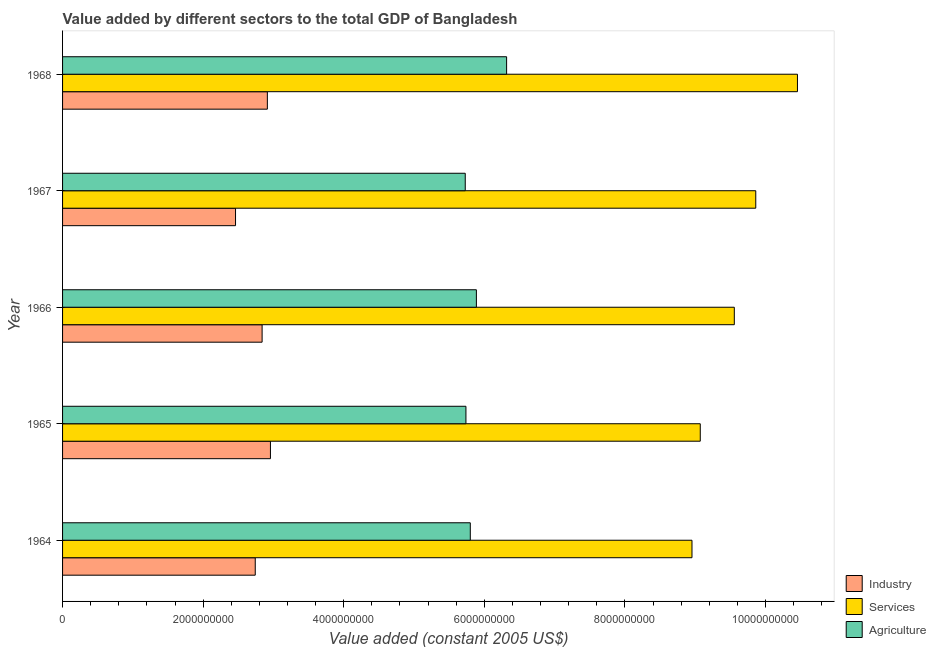Are the number of bars per tick equal to the number of legend labels?
Provide a short and direct response. Yes. What is the label of the 4th group of bars from the top?
Offer a terse response. 1965. What is the value added by services in 1964?
Make the answer very short. 8.95e+09. Across all years, what is the maximum value added by services?
Make the answer very short. 1.05e+1. Across all years, what is the minimum value added by agricultural sector?
Your response must be concise. 5.73e+09. In which year was the value added by agricultural sector maximum?
Your answer should be compact. 1968. In which year was the value added by services minimum?
Offer a very short reply. 1964. What is the total value added by industrial sector in the graph?
Make the answer very short. 1.39e+1. What is the difference between the value added by agricultural sector in 1964 and that in 1967?
Give a very brief answer. 7.18e+07. What is the difference between the value added by agricultural sector in 1964 and the value added by services in 1965?
Ensure brevity in your answer.  -3.27e+09. What is the average value added by industrial sector per year?
Your answer should be very brief. 2.78e+09. In the year 1965, what is the difference between the value added by industrial sector and value added by agricultural sector?
Your answer should be compact. -2.78e+09. What is the ratio of the value added by services in 1965 to that in 1966?
Offer a terse response. 0.95. What is the difference between the highest and the second highest value added by agricultural sector?
Provide a short and direct response. 4.30e+08. What is the difference between the highest and the lowest value added by agricultural sector?
Ensure brevity in your answer.  5.88e+08. Is the sum of the value added by industrial sector in 1964 and 1965 greater than the maximum value added by agricultural sector across all years?
Provide a short and direct response. No. What does the 3rd bar from the top in 1966 represents?
Provide a succinct answer. Industry. What does the 1st bar from the bottom in 1967 represents?
Your answer should be compact. Industry. How many bars are there?
Your response must be concise. 15. Are all the bars in the graph horizontal?
Your response must be concise. Yes. How many years are there in the graph?
Ensure brevity in your answer.  5. Are the values on the major ticks of X-axis written in scientific E-notation?
Offer a very short reply. No. Does the graph contain any zero values?
Make the answer very short. No. How many legend labels are there?
Ensure brevity in your answer.  3. How are the legend labels stacked?
Give a very brief answer. Vertical. What is the title of the graph?
Ensure brevity in your answer.  Value added by different sectors to the total GDP of Bangladesh. What is the label or title of the X-axis?
Your answer should be very brief. Value added (constant 2005 US$). What is the label or title of the Y-axis?
Provide a succinct answer. Year. What is the Value added (constant 2005 US$) of Industry in 1964?
Offer a very short reply. 2.74e+09. What is the Value added (constant 2005 US$) of Services in 1964?
Your answer should be very brief. 8.95e+09. What is the Value added (constant 2005 US$) of Agriculture in 1964?
Offer a very short reply. 5.80e+09. What is the Value added (constant 2005 US$) of Industry in 1965?
Your answer should be compact. 2.96e+09. What is the Value added (constant 2005 US$) of Services in 1965?
Keep it short and to the point. 9.07e+09. What is the Value added (constant 2005 US$) in Agriculture in 1965?
Your response must be concise. 5.74e+09. What is the Value added (constant 2005 US$) in Industry in 1966?
Ensure brevity in your answer.  2.84e+09. What is the Value added (constant 2005 US$) in Services in 1966?
Provide a succinct answer. 9.56e+09. What is the Value added (constant 2005 US$) of Agriculture in 1966?
Offer a very short reply. 5.89e+09. What is the Value added (constant 2005 US$) in Industry in 1967?
Offer a very short reply. 2.46e+09. What is the Value added (constant 2005 US$) in Services in 1967?
Provide a succinct answer. 9.86e+09. What is the Value added (constant 2005 US$) in Agriculture in 1967?
Offer a terse response. 5.73e+09. What is the Value added (constant 2005 US$) in Industry in 1968?
Provide a short and direct response. 2.91e+09. What is the Value added (constant 2005 US$) of Services in 1968?
Make the answer very short. 1.05e+1. What is the Value added (constant 2005 US$) of Agriculture in 1968?
Your answer should be compact. 6.32e+09. Across all years, what is the maximum Value added (constant 2005 US$) in Industry?
Provide a succinct answer. 2.96e+09. Across all years, what is the maximum Value added (constant 2005 US$) in Services?
Ensure brevity in your answer.  1.05e+1. Across all years, what is the maximum Value added (constant 2005 US$) of Agriculture?
Give a very brief answer. 6.32e+09. Across all years, what is the minimum Value added (constant 2005 US$) in Industry?
Provide a short and direct response. 2.46e+09. Across all years, what is the minimum Value added (constant 2005 US$) of Services?
Your response must be concise. 8.95e+09. Across all years, what is the minimum Value added (constant 2005 US$) in Agriculture?
Your answer should be very brief. 5.73e+09. What is the total Value added (constant 2005 US$) of Industry in the graph?
Keep it short and to the point. 1.39e+1. What is the total Value added (constant 2005 US$) of Services in the graph?
Your answer should be compact. 4.79e+1. What is the total Value added (constant 2005 US$) in Agriculture in the graph?
Provide a succinct answer. 2.95e+1. What is the difference between the Value added (constant 2005 US$) of Industry in 1964 and that in 1965?
Provide a short and direct response. -2.16e+08. What is the difference between the Value added (constant 2005 US$) of Services in 1964 and that in 1965?
Keep it short and to the point. -1.18e+08. What is the difference between the Value added (constant 2005 US$) in Agriculture in 1964 and that in 1965?
Your answer should be very brief. 6.19e+07. What is the difference between the Value added (constant 2005 US$) of Industry in 1964 and that in 1966?
Your answer should be very brief. -9.76e+07. What is the difference between the Value added (constant 2005 US$) in Services in 1964 and that in 1966?
Give a very brief answer. -6.02e+08. What is the difference between the Value added (constant 2005 US$) in Agriculture in 1964 and that in 1966?
Give a very brief answer. -8.68e+07. What is the difference between the Value added (constant 2005 US$) of Industry in 1964 and that in 1967?
Your answer should be very brief. 2.81e+08. What is the difference between the Value added (constant 2005 US$) of Services in 1964 and that in 1967?
Make the answer very short. -9.07e+08. What is the difference between the Value added (constant 2005 US$) of Agriculture in 1964 and that in 1967?
Make the answer very short. 7.18e+07. What is the difference between the Value added (constant 2005 US$) of Industry in 1964 and that in 1968?
Ensure brevity in your answer.  -1.72e+08. What is the difference between the Value added (constant 2005 US$) of Services in 1964 and that in 1968?
Your response must be concise. -1.50e+09. What is the difference between the Value added (constant 2005 US$) of Agriculture in 1964 and that in 1968?
Provide a short and direct response. -5.17e+08. What is the difference between the Value added (constant 2005 US$) in Industry in 1965 and that in 1966?
Your response must be concise. 1.19e+08. What is the difference between the Value added (constant 2005 US$) of Services in 1965 and that in 1966?
Offer a very short reply. -4.84e+08. What is the difference between the Value added (constant 2005 US$) in Agriculture in 1965 and that in 1966?
Offer a very short reply. -1.49e+08. What is the difference between the Value added (constant 2005 US$) of Industry in 1965 and that in 1967?
Provide a short and direct response. 4.97e+08. What is the difference between the Value added (constant 2005 US$) of Services in 1965 and that in 1967?
Make the answer very short. -7.89e+08. What is the difference between the Value added (constant 2005 US$) in Agriculture in 1965 and that in 1967?
Ensure brevity in your answer.  9.92e+06. What is the difference between the Value added (constant 2005 US$) in Industry in 1965 and that in 1968?
Provide a succinct answer. 4.39e+07. What is the difference between the Value added (constant 2005 US$) of Services in 1965 and that in 1968?
Provide a short and direct response. -1.38e+09. What is the difference between the Value added (constant 2005 US$) of Agriculture in 1965 and that in 1968?
Ensure brevity in your answer.  -5.78e+08. What is the difference between the Value added (constant 2005 US$) in Industry in 1966 and that in 1967?
Make the answer very short. 3.78e+08. What is the difference between the Value added (constant 2005 US$) of Services in 1966 and that in 1967?
Ensure brevity in your answer.  -3.05e+08. What is the difference between the Value added (constant 2005 US$) of Agriculture in 1966 and that in 1967?
Offer a terse response. 1.59e+08. What is the difference between the Value added (constant 2005 US$) of Industry in 1966 and that in 1968?
Provide a succinct answer. -7.46e+07. What is the difference between the Value added (constant 2005 US$) in Services in 1966 and that in 1968?
Give a very brief answer. -8.98e+08. What is the difference between the Value added (constant 2005 US$) in Agriculture in 1966 and that in 1968?
Your answer should be very brief. -4.30e+08. What is the difference between the Value added (constant 2005 US$) in Industry in 1967 and that in 1968?
Your answer should be very brief. -4.53e+08. What is the difference between the Value added (constant 2005 US$) of Services in 1967 and that in 1968?
Your answer should be compact. -5.93e+08. What is the difference between the Value added (constant 2005 US$) of Agriculture in 1967 and that in 1968?
Your answer should be very brief. -5.88e+08. What is the difference between the Value added (constant 2005 US$) of Industry in 1964 and the Value added (constant 2005 US$) of Services in 1965?
Offer a very short reply. -6.33e+09. What is the difference between the Value added (constant 2005 US$) in Industry in 1964 and the Value added (constant 2005 US$) in Agriculture in 1965?
Offer a very short reply. -3.00e+09. What is the difference between the Value added (constant 2005 US$) in Services in 1964 and the Value added (constant 2005 US$) in Agriculture in 1965?
Your answer should be very brief. 3.22e+09. What is the difference between the Value added (constant 2005 US$) in Industry in 1964 and the Value added (constant 2005 US$) in Services in 1966?
Give a very brief answer. -6.82e+09. What is the difference between the Value added (constant 2005 US$) in Industry in 1964 and the Value added (constant 2005 US$) in Agriculture in 1966?
Make the answer very short. -3.15e+09. What is the difference between the Value added (constant 2005 US$) of Services in 1964 and the Value added (constant 2005 US$) of Agriculture in 1966?
Provide a succinct answer. 3.07e+09. What is the difference between the Value added (constant 2005 US$) of Industry in 1964 and the Value added (constant 2005 US$) of Services in 1967?
Your answer should be compact. -7.12e+09. What is the difference between the Value added (constant 2005 US$) in Industry in 1964 and the Value added (constant 2005 US$) in Agriculture in 1967?
Your answer should be very brief. -2.99e+09. What is the difference between the Value added (constant 2005 US$) in Services in 1964 and the Value added (constant 2005 US$) in Agriculture in 1967?
Ensure brevity in your answer.  3.23e+09. What is the difference between the Value added (constant 2005 US$) of Industry in 1964 and the Value added (constant 2005 US$) of Services in 1968?
Your response must be concise. -7.71e+09. What is the difference between the Value added (constant 2005 US$) of Industry in 1964 and the Value added (constant 2005 US$) of Agriculture in 1968?
Provide a short and direct response. -3.58e+09. What is the difference between the Value added (constant 2005 US$) in Services in 1964 and the Value added (constant 2005 US$) in Agriculture in 1968?
Your answer should be compact. 2.64e+09. What is the difference between the Value added (constant 2005 US$) of Industry in 1965 and the Value added (constant 2005 US$) of Services in 1966?
Your answer should be very brief. -6.60e+09. What is the difference between the Value added (constant 2005 US$) of Industry in 1965 and the Value added (constant 2005 US$) of Agriculture in 1966?
Make the answer very short. -2.93e+09. What is the difference between the Value added (constant 2005 US$) in Services in 1965 and the Value added (constant 2005 US$) in Agriculture in 1966?
Give a very brief answer. 3.18e+09. What is the difference between the Value added (constant 2005 US$) of Industry in 1965 and the Value added (constant 2005 US$) of Services in 1967?
Keep it short and to the point. -6.90e+09. What is the difference between the Value added (constant 2005 US$) in Industry in 1965 and the Value added (constant 2005 US$) in Agriculture in 1967?
Provide a short and direct response. -2.77e+09. What is the difference between the Value added (constant 2005 US$) of Services in 1965 and the Value added (constant 2005 US$) of Agriculture in 1967?
Offer a very short reply. 3.34e+09. What is the difference between the Value added (constant 2005 US$) of Industry in 1965 and the Value added (constant 2005 US$) of Services in 1968?
Your answer should be compact. -7.50e+09. What is the difference between the Value added (constant 2005 US$) in Industry in 1965 and the Value added (constant 2005 US$) in Agriculture in 1968?
Offer a terse response. -3.36e+09. What is the difference between the Value added (constant 2005 US$) in Services in 1965 and the Value added (constant 2005 US$) in Agriculture in 1968?
Give a very brief answer. 2.76e+09. What is the difference between the Value added (constant 2005 US$) of Industry in 1966 and the Value added (constant 2005 US$) of Services in 1967?
Ensure brevity in your answer.  -7.02e+09. What is the difference between the Value added (constant 2005 US$) of Industry in 1966 and the Value added (constant 2005 US$) of Agriculture in 1967?
Offer a very short reply. -2.89e+09. What is the difference between the Value added (constant 2005 US$) of Services in 1966 and the Value added (constant 2005 US$) of Agriculture in 1967?
Offer a terse response. 3.83e+09. What is the difference between the Value added (constant 2005 US$) of Industry in 1966 and the Value added (constant 2005 US$) of Services in 1968?
Ensure brevity in your answer.  -7.62e+09. What is the difference between the Value added (constant 2005 US$) in Industry in 1966 and the Value added (constant 2005 US$) in Agriculture in 1968?
Offer a very short reply. -3.48e+09. What is the difference between the Value added (constant 2005 US$) in Services in 1966 and the Value added (constant 2005 US$) in Agriculture in 1968?
Your answer should be compact. 3.24e+09. What is the difference between the Value added (constant 2005 US$) of Industry in 1967 and the Value added (constant 2005 US$) of Services in 1968?
Your answer should be very brief. -7.99e+09. What is the difference between the Value added (constant 2005 US$) in Industry in 1967 and the Value added (constant 2005 US$) in Agriculture in 1968?
Keep it short and to the point. -3.86e+09. What is the difference between the Value added (constant 2005 US$) in Services in 1967 and the Value added (constant 2005 US$) in Agriculture in 1968?
Your answer should be very brief. 3.54e+09. What is the average Value added (constant 2005 US$) of Industry per year?
Offer a very short reply. 2.78e+09. What is the average Value added (constant 2005 US$) of Services per year?
Keep it short and to the point. 9.58e+09. What is the average Value added (constant 2005 US$) in Agriculture per year?
Offer a very short reply. 5.89e+09. In the year 1964, what is the difference between the Value added (constant 2005 US$) in Industry and Value added (constant 2005 US$) in Services?
Offer a very short reply. -6.21e+09. In the year 1964, what is the difference between the Value added (constant 2005 US$) in Industry and Value added (constant 2005 US$) in Agriculture?
Keep it short and to the point. -3.06e+09. In the year 1964, what is the difference between the Value added (constant 2005 US$) of Services and Value added (constant 2005 US$) of Agriculture?
Give a very brief answer. 3.15e+09. In the year 1965, what is the difference between the Value added (constant 2005 US$) in Industry and Value added (constant 2005 US$) in Services?
Offer a very short reply. -6.11e+09. In the year 1965, what is the difference between the Value added (constant 2005 US$) in Industry and Value added (constant 2005 US$) in Agriculture?
Ensure brevity in your answer.  -2.78e+09. In the year 1965, what is the difference between the Value added (constant 2005 US$) of Services and Value added (constant 2005 US$) of Agriculture?
Make the answer very short. 3.33e+09. In the year 1966, what is the difference between the Value added (constant 2005 US$) of Industry and Value added (constant 2005 US$) of Services?
Your answer should be very brief. -6.72e+09. In the year 1966, what is the difference between the Value added (constant 2005 US$) in Industry and Value added (constant 2005 US$) in Agriculture?
Your answer should be compact. -3.05e+09. In the year 1966, what is the difference between the Value added (constant 2005 US$) of Services and Value added (constant 2005 US$) of Agriculture?
Keep it short and to the point. 3.67e+09. In the year 1967, what is the difference between the Value added (constant 2005 US$) in Industry and Value added (constant 2005 US$) in Services?
Make the answer very short. -7.40e+09. In the year 1967, what is the difference between the Value added (constant 2005 US$) of Industry and Value added (constant 2005 US$) of Agriculture?
Your answer should be compact. -3.27e+09. In the year 1967, what is the difference between the Value added (constant 2005 US$) of Services and Value added (constant 2005 US$) of Agriculture?
Offer a very short reply. 4.13e+09. In the year 1968, what is the difference between the Value added (constant 2005 US$) in Industry and Value added (constant 2005 US$) in Services?
Provide a succinct answer. -7.54e+09. In the year 1968, what is the difference between the Value added (constant 2005 US$) of Industry and Value added (constant 2005 US$) of Agriculture?
Offer a very short reply. -3.40e+09. In the year 1968, what is the difference between the Value added (constant 2005 US$) in Services and Value added (constant 2005 US$) in Agriculture?
Give a very brief answer. 4.14e+09. What is the ratio of the Value added (constant 2005 US$) in Industry in 1964 to that in 1965?
Give a very brief answer. 0.93. What is the ratio of the Value added (constant 2005 US$) in Services in 1964 to that in 1965?
Keep it short and to the point. 0.99. What is the ratio of the Value added (constant 2005 US$) in Agriculture in 1964 to that in 1965?
Provide a short and direct response. 1.01. What is the ratio of the Value added (constant 2005 US$) of Industry in 1964 to that in 1966?
Your response must be concise. 0.97. What is the ratio of the Value added (constant 2005 US$) in Services in 1964 to that in 1966?
Offer a very short reply. 0.94. What is the ratio of the Value added (constant 2005 US$) of Agriculture in 1964 to that in 1966?
Your answer should be very brief. 0.99. What is the ratio of the Value added (constant 2005 US$) of Industry in 1964 to that in 1967?
Your response must be concise. 1.11. What is the ratio of the Value added (constant 2005 US$) of Services in 1964 to that in 1967?
Keep it short and to the point. 0.91. What is the ratio of the Value added (constant 2005 US$) of Agriculture in 1964 to that in 1967?
Offer a very short reply. 1.01. What is the ratio of the Value added (constant 2005 US$) of Industry in 1964 to that in 1968?
Offer a terse response. 0.94. What is the ratio of the Value added (constant 2005 US$) of Services in 1964 to that in 1968?
Provide a succinct answer. 0.86. What is the ratio of the Value added (constant 2005 US$) in Agriculture in 1964 to that in 1968?
Ensure brevity in your answer.  0.92. What is the ratio of the Value added (constant 2005 US$) in Industry in 1965 to that in 1966?
Provide a succinct answer. 1.04. What is the ratio of the Value added (constant 2005 US$) in Services in 1965 to that in 1966?
Offer a very short reply. 0.95. What is the ratio of the Value added (constant 2005 US$) in Agriculture in 1965 to that in 1966?
Your response must be concise. 0.97. What is the ratio of the Value added (constant 2005 US$) in Industry in 1965 to that in 1967?
Ensure brevity in your answer.  1.2. What is the ratio of the Value added (constant 2005 US$) of Services in 1965 to that in 1967?
Ensure brevity in your answer.  0.92. What is the ratio of the Value added (constant 2005 US$) in Industry in 1965 to that in 1968?
Offer a very short reply. 1.02. What is the ratio of the Value added (constant 2005 US$) in Services in 1965 to that in 1968?
Your answer should be very brief. 0.87. What is the ratio of the Value added (constant 2005 US$) of Agriculture in 1965 to that in 1968?
Offer a terse response. 0.91. What is the ratio of the Value added (constant 2005 US$) of Industry in 1966 to that in 1967?
Make the answer very short. 1.15. What is the ratio of the Value added (constant 2005 US$) in Services in 1966 to that in 1967?
Ensure brevity in your answer.  0.97. What is the ratio of the Value added (constant 2005 US$) of Agriculture in 1966 to that in 1967?
Keep it short and to the point. 1.03. What is the ratio of the Value added (constant 2005 US$) in Industry in 1966 to that in 1968?
Your answer should be compact. 0.97. What is the ratio of the Value added (constant 2005 US$) of Services in 1966 to that in 1968?
Your answer should be compact. 0.91. What is the ratio of the Value added (constant 2005 US$) in Agriculture in 1966 to that in 1968?
Offer a terse response. 0.93. What is the ratio of the Value added (constant 2005 US$) of Industry in 1967 to that in 1968?
Provide a short and direct response. 0.84. What is the ratio of the Value added (constant 2005 US$) in Services in 1967 to that in 1968?
Your response must be concise. 0.94. What is the ratio of the Value added (constant 2005 US$) of Agriculture in 1967 to that in 1968?
Your response must be concise. 0.91. What is the difference between the highest and the second highest Value added (constant 2005 US$) of Industry?
Offer a very short reply. 4.39e+07. What is the difference between the highest and the second highest Value added (constant 2005 US$) in Services?
Offer a very short reply. 5.93e+08. What is the difference between the highest and the second highest Value added (constant 2005 US$) of Agriculture?
Keep it short and to the point. 4.30e+08. What is the difference between the highest and the lowest Value added (constant 2005 US$) in Industry?
Your answer should be very brief. 4.97e+08. What is the difference between the highest and the lowest Value added (constant 2005 US$) of Services?
Your answer should be compact. 1.50e+09. What is the difference between the highest and the lowest Value added (constant 2005 US$) of Agriculture?
Offer a very short reply. 5.88e+08. 